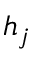<formula> <loc_0><loc_0><loc_500><loc_500>h _ { j }</formula> 